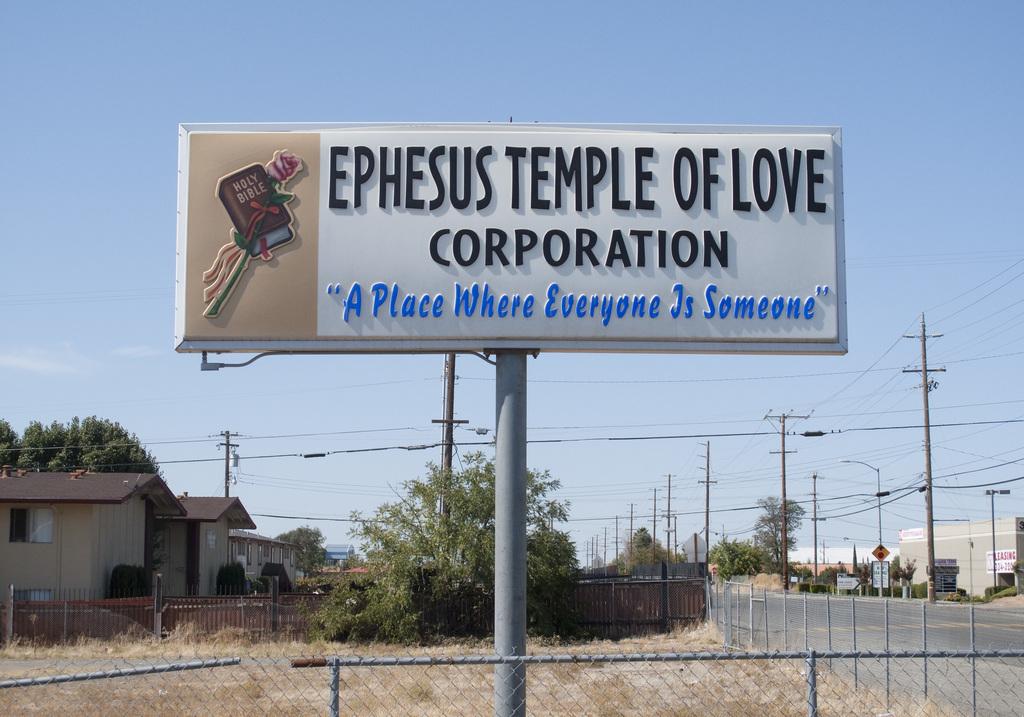What is the slogan for this temple of love?
Make the answer very short. A place where everyone is someone. Temple of what?
Make the answer very short. Love. 